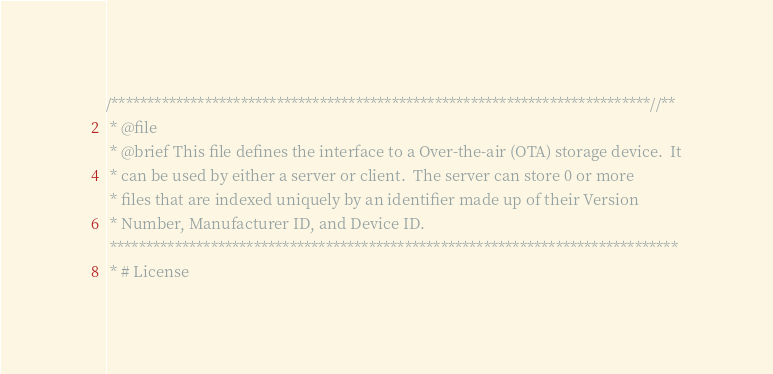<code> <loc_0><loc_0><loc_500><loc_500><_C_>/***************************************************************************//**
 * @file
 * @brief This file defines the interface to a Over-the-air (OTA) storage device.  It
 * can be used by either a server or client.  The server can store 0 or more
 * files that are indexed uniquely by an identifier made up of their Version
 * Number, Manufacturer ID, and Device ID.
 *******************************************************************************
 * # License</code> 